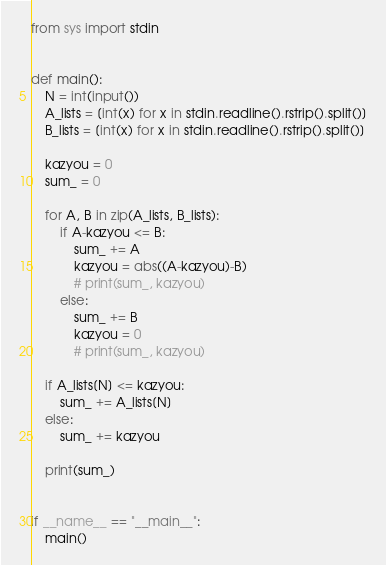Convert code to text. <code><loc_0><loc_0><loc_500><loc_500><_Python_>from sys import stdin


def main():
    N = int(input())
    A_lists = [int(x) for x in stdin.readline().rstrip().split()]
    B_lists = [int(x) for x in stdin.readline().rstrip().split()]

    kazyou = 0
    sum_ = 0

    for A, B in zip(A_lists, B_lists):
        if A-kazyou <= B:
            sum_ += A
            kazyou = abs((A-kazyou)-B)
            # print(sum_, kazyou)
        else:
            sum_ += B
            kazyou = 0
            # print(sum_, kazyou)

    if A_lists[N] <= kazyou:
        sum_ += A_lists[N]
    else:
        sum_ += kazyou

    print(sum_)


if __name__ == "__main__":
    main()
</code> 